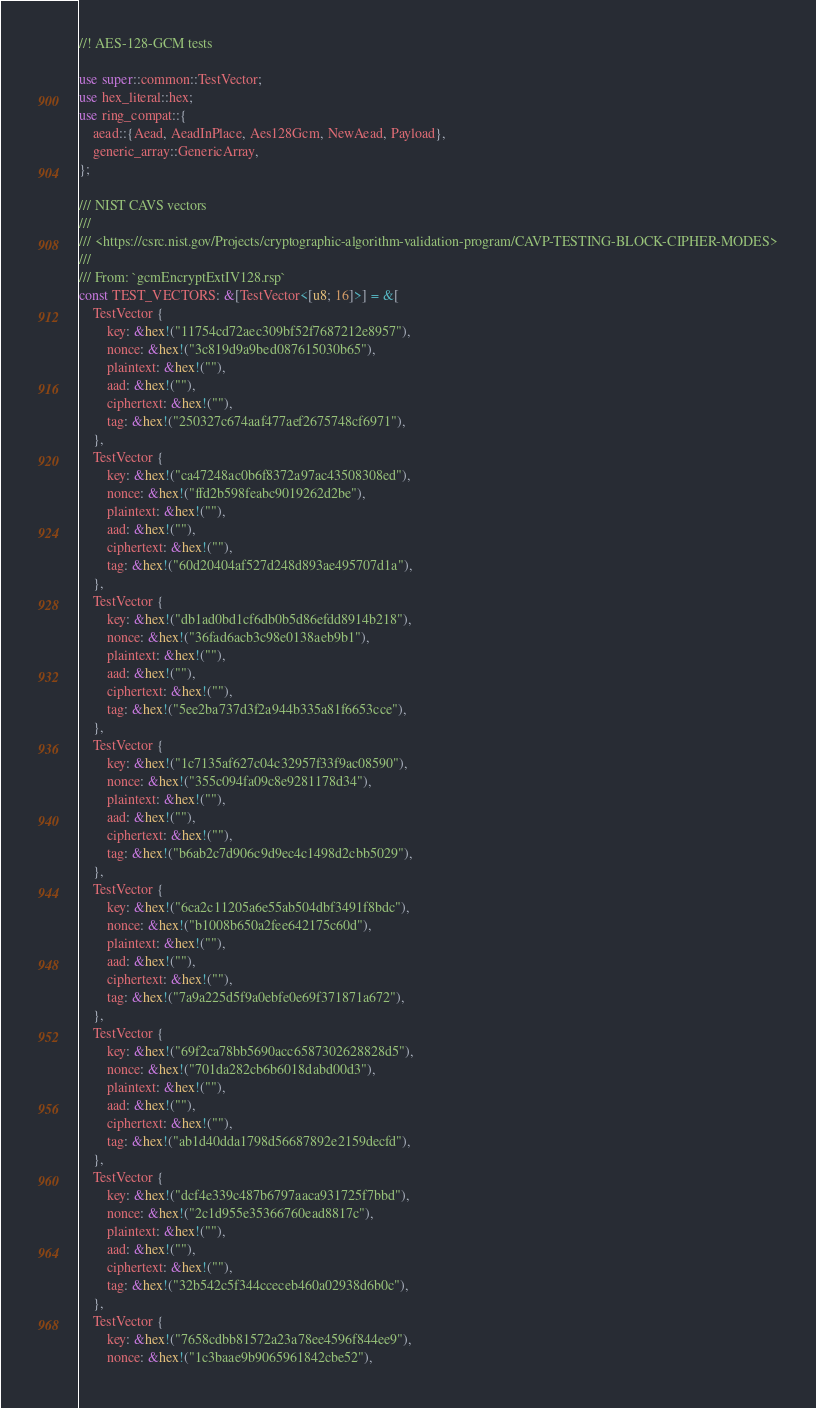<code> <loc_0><loc_0><loc_500><loc_500><_Rust_>//! AES-128-GCM tests

use super::common::TestVector;
use hex_literal::hex;
use ring_compat::{
    aead::{Aead, AeadInPlace, Aes128Gcm, NewAead, Payload},
    generic_array::GenericArray,
};

/// NIST CAVS vectors
///
/// <https://csrc.nist.gov/Projects/cryptographic-algorithm-validation-program/CAVP-TESTING-BLOCK-CIPHER-MODES>
///
/// From: `gcmEncryptExtIV128.rsp`
const TEST_VECTORS: &[TestVector<[u8; 16]>] = &[
    TestVector {
        key: &hex!("11754cd72aec309bf52f7687212e8957"),
        nonce: &hex!("3c819d9a9bed087615030b65"),
        plaintext: &hex!(""),
        aad: &hex!(""),
        ciphertext: &hex!(""),
        tag: &hex!("250327c674aaf477aef2675748cf6971"),
    },
    TestVector {
        key: &hex!("ca47248ac0b6f8372a97ac43508308ed"),
        nonce: &hex!("ffd2b598feabc9019262d2be"),
        plaintext: &hex!(""),
        aad: &hex!(""),
        ciphertext: &hex!(""),
        tag: &hex!("60d20404af527d248d893ae495707d1a"),
    },
    TestVector {
        key: &hex!("db1ad0bd1cf6db0b5d86efdd8914b218"),
        nonce: &hex!("36fad6acb3c98e0138aeb9b1"),
        plaintext: &hex!(""),
        aad: &hex!(""),
        ciphertext: &hex!(""),
        tag: &hex!("5ee2ba737d3f2a944b335a81f6653cce"),
    },
    TestVector {
        key: &hex!("1c7135af627c04c32957f33f9ac08590"),
        nonce: &hex!("355c094fa09c8e9281178d34"),
        plaintext: &hex!(""),
        aad: &hex!(""),
        ciphertext: &hex!(""),
        tag: &hex!("b6ab2c7d906c9d9ec4c1498d2cbb5029"),
    },
    TestVector {
        key: &hex!("6ca2c11205a6e55ab504dbf3491f8bdc"),
        nonce: &hex!("b1008b650a2fee642175c60d"),
        plaintext: &hex!(""),
        aad: &hex!(""),
        ciphertext: &hex!(""),
        tag: &hex!("7a9a225d5f9a0ebfe0e69f371871a672"),
    },
    TestVector {
        key: &hex!("69f2ca78bb5690acc6587302628828d5"),
        nonce: &hex!("701da282cb6b6018dabd00d3"),
        plaintext: &hex!(""),
        aad: &hex!(""),
        ciphertext: &hex!(""),
        tag: &hex!("ab1d40dda1798d56687892e2159decfd"),
    },
    TestVector {
        key: &hex!("dcf4e339c487b6797aaca931725f7bbd"),
        nonce: &hex!("2c1d955e35366760ead8817c"),
        plaintext: &hex!(""),
        aad: &hex!(""),
        ciphertext: &hex!(""),
        tag: &hex!("32b542c5f344cceceb460a02938d6b0c"),
    },
    TestVector {
        key: &hex!("7658cdbb81572a23a78ee4596f844ee9"),
        nonce: &hex!("1c3baae9b9065961842cbe52"),</code> 